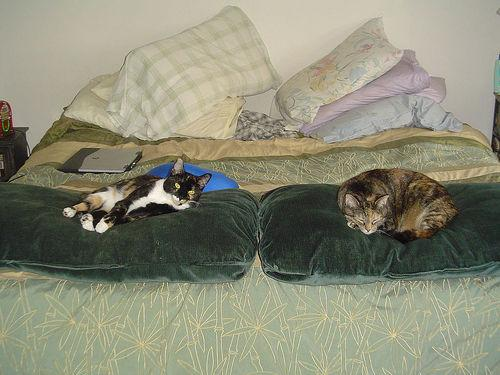Describe the overall sentiment or atmosphere conveyed by the image. The image conveys a cozy and peaceful sentiment with cats resting on comfortable and colorful pillows. Determine the total number of pillows in the picture and briefly describe their arrangement. There are six pillows arranged in two stacks on the bed: two green, one blue, one purple and blue, and two with floral cases. Analyze the interaction of the two main subjects of the image. The two cats, one calico and one black and white, are laying down on pillows with a relaxed and comfortable interaction. Identify the primary object in the scene and describe its primary activity. A calico cat on a pillow is the main object, which appears to be sleeping or resting. Please provide a brief description of the room's focal point. The main focus of the room is the bed where two cats are lying on the pillow. How many cats are in the picture and what are their appearances? There are two cats: a calico cat and a black and white cat, both laying down. Estimate the total number of objects in the image and list the categories they belong to. There are around 16 objects: two cats, six pillows, a laptop, a comforter, a bed, a bed side table, a wall and a logo. 